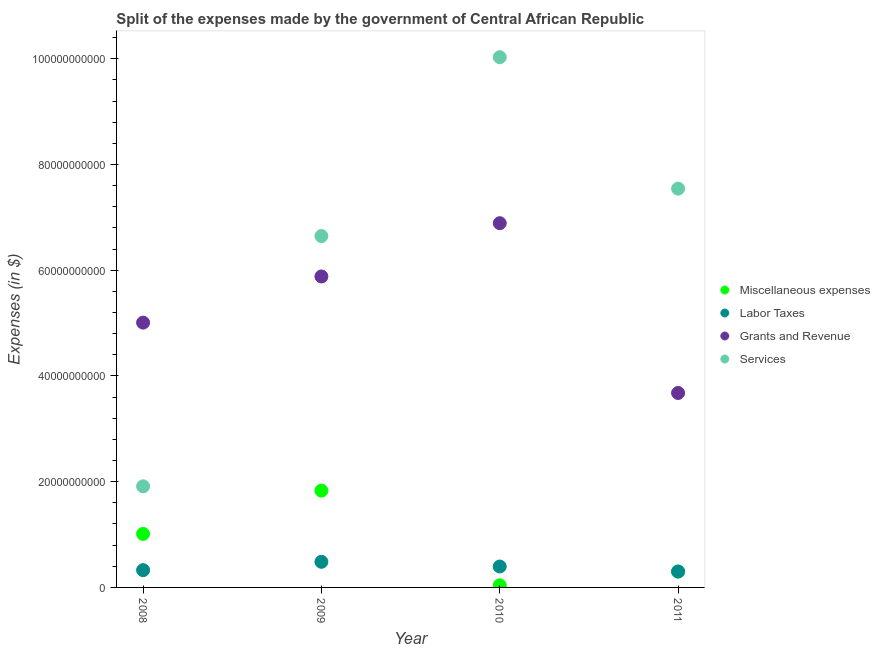How many different coloured dotlines are there?
Provide a short and direct response. 4. What is the amount spent on labor taxes in 2011?
Provide a succinct answer. 3.01e+09. Across all years, what is the maximum amount spent on labor taxes?
Offer a terse response. 4.84e+09. Across all years, what is the minimum amount spent on labor taxes?
Ensure brevity in your answer.  3.01e+09. What is the total amount spent on services in the graph?
Ensure brevity in your answer.  2.61e+11. What is the difference between the amount spent on services in 2009 and that in 2010?
Your answer should be very brief. -3.38e+1. What is the difference between the amount spent on services in 2011 and the amount spent on grants and revenue in 2009?
Your response must be concise. 1.66e+1. What is the average amount spent on labor taxes per year?
Ensure brevity in your answer.  3.77e+09. In the year 2010, what is the difference between the amount spent on grants and revenue and amount spent on services?
Offer a very short reply. -3.14e+1. What is the ratio of the amount spent on grants and revenue in 2009 to that in 2011?
Your answer should be very brief. 1.6. What is the difference between the highest and the second highest amount spent on labor taxes?
Provide a succinct answer. 8.89e+08. What is the difference between the highest and the lowest amount spent on labor taxes?
Your answer should be very brief. 1.84e+09. In how many years, is the amount spent on labor taxes greater than the average amount spent on labor taxes taken over all years?
Provide a succinct answer. 2. Is it the case that in every year, the sum of the amount spent on labor taxes and amount spent on miscellaneous expenses is greater than the sum of amount spent on services and amount spent on grants and revenue?
Your answer should be compact. No. Is it the case that in every year, the sum of the amount spent on miscellaneous expenses and amount spent on labor taxes is greater than the amount spent on grants and revenue?
Offer a terse response. No. Does the amount spent on services monotonically increase over the years?
Give a very brief answer. No. Is the amount spent on grants and revenue strictly greater than the amount spent on labor taxes over the years?
Ensure brevity in your answer.  Yes. Is the amount spent on miscellaneous expenses strictly less than the amount spent on grants and revenue over the years?
Offer a very short reply. Yes. How many years are there in the graph?
Offer a very short reply. 4. Are the values on the major ticks of Y-axis written in scientific E-notation?
Your answer should be compact. No. Does the graph contain any zero values?
Your answer should be compact. No. Does the graph contain grids?
Your response must be concise. No. Where does the legend appear in the graph?
Make the answer very short. Center right. What is the title of the graph?
Your answer should be very brief. Split of the expenses made by the government of Central African Republic. Does "Environmental sustainability" appear as one of the legend labels in the graph?
Offer a very short reply. No. What is the label or title of the Y-axis?
Ensure brevity in your answer.  Expenses (in $). What is the Expenses (in $) of Miscellaneous expenses in 2008?
Make the answer very short. 1.01e+1. What is the Expenses (in $) in Labor Taxes in 2008?
Offer a terse response. 3.27e+09. What is the Expenses (in $) in Grants and Revenue in 2008?
Give a very brief answer. 5.01e+1. What is the Expenses (in $) of Services in 2008?
Provide a succinct answer. 1.91e+1. What is the Expenses (in $) in Miscellaneous expenses in 2009?
Offer a terse response. 1.83e+1. What is the Expenses (in $) in Labor Taxes in 2009?
Make the answer very short. 4.84e+09. What is the Expenses (in $) in Grants and Revenue in 2009?
Your answer should be very brief. 5.88e+1. What is the Expenses (in $) in Services in 2009?
Your response must be concise. 6.65e+1. What is the Expenses (in $) of Miscellaneous expenses in 2010?
Provide a succinct answer. 4.00e+08. What is the Expenses (in $) of Labor Taxes in 2010?
Provide a succinct answer. 3.96e+09. What is the Expenses (in $) in Grants and Revenue in 2010?
Offer a terse response. 6.89e+1. What is the Expenses (in $) in Services in 2010?
Your answer should be compact. 1.00e+11. What is the Expenses (in $) in Miscellaneous expenses in 2011?
Provide a short and direct response. 3.00e+09. What is the Expenses (in $) of Labor Taxes in 2011?
Provide a short and direct response. 3.01e+09. What is the Expenses (in $) in Grants and Revenue in 2011?
Make the answer very short. 3.68e+1. What is the Expenses (in $) of Services in 2011?
Provide a succinct answer. 7.54e+1. Across all years, what is the maximum Expenses (in $) in Miscellaneous expenses?
Give a very brief answer. 1.83e+1. Across all years, what is the maximum Expenses (in $) of Labor Taxes?
Provide a short and direct response. 4.84e+09. Across all years, what is the maximum Expenses (in $) of Grants and Revenue?
Your answer should be compact. 6.89e+1. Across all years, what is the maximum Expenses (in $) in Services?
Make the answer very short. 1.00e+11. Across all years, what is the minimum Expenses (in $) in Miscellaneous expenses?
Your response must be concise. 4.00e+08. Across all years, what is the minimum Expenses (in $) in Labor Taxes?
Give a very brief answer. 3.01e+09. Across all years, what is the minimum Expenses (in $) in Grants and Revenue?
Offer a terse response. 3.68e+1. Across all years, what is the minimum Expenses (in $) in Services?
Ensure brevity in your answer.  1.91e+1. What is the total Expenses (in $) in Miscellaneous expenses in the graph?
Give a very brief answer. 3.18e+1. What is the total Expenses (in $) of Labor Taxes in the graph?
Provide a succinct answer. 1.51e+1. What is the total Expenses (in $) of Grants and Revenue in the graph?
Make the answer very short. 2.15e+11. What is the total Expenses (in $) of Services in the graph?
Provide a short and direct response. 2.61e+11. What is the difference between the Expenses (in $) in Miscellaneous expenses in 2008 and that in 2009?
Keep it short and to the point. -8.19e+09. What is the difference between the Expenses (in $) in Labor Taxes in 2008 and that in 2009?
Offer a very short reply. -1.58e+09. What is the difference between the Expenses (in $) of Grants and Revenue in 2008 and that in 2009?
Offer a very short reply. -8.74e+09. What is the difference between the Expenses (in $) of Services in 2008 and that in 2009?
Provide a succinct answer. -4.73e+1. What is the difference between the Expenses (in $) in Miscellaneous expenses in 2008 and that in 2010?
Ensure brevity in your answer.  9.72e+09. What is the difference between the Expenses (in $) in Labor Taxes in 2008 and that in 2010?
Provide a succinct answer. -6.89e+08. What is the difference between the Expenses (in $) of Grants and Revenue in 2008 and that in 2010?
Your answer should be compact. -1.88e+1. What is the difference between the Expenses (in $) in Services in 2008 and that in 2010?
Offer a very short reply. -8.12e+1. What is the difference between the Expenses (in $) of Miscellaneous expenses in 2008 and that in 2011?
Make the answer very short. 7.12e+09. What is the difference between the Expenses (in $) in Labor Taxes in 2008 and that in 2011?
Your answer should be very brief. 2.58e+08. What is the difference between the Expenses (in $) in Grants and Revenue in 2008 and that in 2011?
Your answer should be very brief. 1.33e+1. What is the difference between the Expenses (in $) of Services in 2008 and that in 2011?
Give a very brief answer. -5.63e+1. What is the difference between the Expenses (in $) of Miscellaneous expenses in 2009 and that in 2010?
Your response must be concise. 1.79e+1. What is the difference between the Expenses (in $) in Labor Taxes in 2009 and that in 2010?
Provide a short and direct response. 8.89e+08. What is the difference between the Expenses (in $) in Grants and Revenue in 2009 and that in 2010?
Offer a terse response. -1.01e+1. What is the difference between the Expenses (in $) in Services in 2009 and that in 2010?
Provide a short and direct response. -3.38e+1. What is the difference between the Expenses (in $) of Miscellaneous expenses in 2009 and that in 2011?
Your answer should be very brief. 1.53e+1. What is the difference between the Expenses (in $) of Labor Taxes in 2009 and that in 2011?
Give a very brief answer. 1.84e+09. What is the difference between the Expenses (in $) in Grants and Revenue in 2009 and that in 2011?
Your response must be concise. 2.20e+1. What is the difference between the Expenses (in $) of Services in 2009 and that in 2011?
Offer a very short reply. -8.97e+09. What is the difference between the Expenses (in $) in Miscellaneous expenses in 2010 and that in 2011?
Provide a succinct answer. -2.60e+09. What is the difference between the Expenses (in $) of Labor Taxes in 2010 and that in 2011?
Provide a short and direct response. 9.47e+08. What is the difference between the Expenses (in $) in Grants and Revenue in 2010 and that in 2011?
Give a very brief answer. 3.21e+1. What is the difference between the Expenses (in $) in Services in 2010 and that in 2011?
Your answer should be very brief. 2.49e+1. What is the difference between the Expenses (in $) of Miscellaneous expenses in 2008 and the Expenses (in $) of Labor Taxes in 2009?
Keep it short and to the point. 5.28e+09. What is the difference between the Expenses (in $) of Miscellaneous expenses in 2008 and the Expenses (in $) of Grants and Revenue in 2009?
Ensure brevity in your answer.  -4.87e+1. What is the difference between the Expenses (in $) of Miscellaneous expenses in 2008 and the Expenses (in $) of Services in 2009?
Your answer should be compact. -5.63e+1. What is the difference between the Expenses (in $) of Labor Taxes in 2008 and the Expenses (in $) of Grants and Revenue in 2009?
Your answer should be compact. -5.56e+1. What is the difference between the Expenses (in $) in Labor Taxes in 2008 and the Expenses (in $) in Services in 2009?
Give a very brief answer. -6.32e+1. What is the difference between the Expenses (in $) of Grants and Revenue in 2008 and the Expenses (in $) of Services in 2009?
Provide a short and direct response. -1.64e+1. What is the difference between the Expenses (in $) in Miscellaneous expenses in 2008 and the Expenses (in $) in Labor Taxes in 2010?
Give a very brief answer. 6.17e+09. What is the difference between the Expenses (in $) in Miscellaneous expenses in 2008 and the Expenses (in $) in Grants and Revenue in 2010?
Your answer should be compact. -5.88e+1. What is the difference between the Expenses (in $) in Miscellaneous expenses in 2008 and the Expenses (in $) in Services in 2010?
Provide a succinct answer. -9.02e+1. What is the difference between the Expenses (in $) of Labor Taxes in 2008 and the Expenses (in $) of Grants and Revenue in 2010?
Provide a succinct answer. -6.56e+1. What is the difference between the Expenses (in $) of Labor Taxes in 2008 and the Expenses (in $) of Services in 2010?
Make the answer very short. -9.70e+1. What is the difference between the Expenses (in $) of Grants and Revenue in 2008 and the Expenses (in $) of Services in 2010?
Your response must be concise. -5.02e+1. What is the difference between the Expenses (in $) of Miscellaneous expenses in 2008 and the Expenses (in $) of Labor Taxes in 2011?
Offer a very short reply. 7.11e+09. What is the difference between the Expenses (in $) in Miscellaneous expenses in 2008 and the Expenses (in $) in Grants and Revenue in 2011?
Your response must be concise. -2.67e+1. What is the difference between the Expenses (in $) in Miscellaneous expenses in 2008 and the Expenses (in $) in Services in 2011?
Your answer should be very brief. -6.53e+1. What is the difference between the Expenses (in $) in Labor Taxes in 2008 and the Expenses (in $) in Grants and Revenue in 2011?
Ensure brevity in your answer.  -3.35e+1. What is the difference between the Expenses (in $) in Labor Taxes in 2008 and the Expenses (in $) in Services in 2011?
Your answer should be very brief. -7.22e+1. What is the difference between the Expenses (in $) in Grants and Revenue in 2008 and the Expenses (in $) in Services in 2011?
Offer a terse response. -2.53e+1. What is the difference between the Expenses (in $) of Miscellaneous expenses in 2009 and the Expenses (in $) of Labor Taxes in 2010?
Keep it short and to the point. 1.44e+1. What is the difference between the Expenses (in $) in Miscellaneous expenses in 2009 and the Expenses (in $) in Grants and Revenue in 2010?
Ensure brevity in your answer.  -5.06e+1. What is the difference between the Expenses (in $) in Miscellaneous expenses in 2009 and the Expenses (in $) in Services in 2010?
Provide a short and direct response. -8.20e+1. What is the difference between the Expenses (in $) in Labor Taxes in 2009 and the Expenses (in $) in Grants and Revenue in 2010?
Offer a very short reply. -6.41e+1. What is the difference between the Expenses (in $) in Labor Taxes in 2009 and the Expenses (in $) in Services in 2010?
Your answer should be compact. -9.54e+1. What is the difference between the Expenses (in $) in Grants and Revenue in 2009 and the Expenses (in $) in Services in 2010?
Keep it short and to the point. -4.15e+1. What is the difference between the Expenses (in $) in Miscellaneous expenses in 2009 and the Expenses (in $) in Labor Taxes in 2011?
Ensure brevity in your answer.  1.53e+1. What is the difference between the Expenses (in $) in Miscellaneous expenses in 2009 and the Expenses (in $) in Grants and Revenue in 2011?
Give a very brief answer. -1.85e+1. What is the difference between the Expenses (in $) of Miscellaneous expenses in 2009 and the Expenses (in $) of Services in 2011?
Your answer should be very brief. -5.71e+1. What is the difference between the Expenses (in $) in Labor Taxes in 2009 and the Expenses (in $) in Grants and Revenue in 2011?
Make the answer very short. -3.19e+1. What is the difference between the Expenses (in $) of Labor Taxes in 2009 and the Expenses (in $) of Services in 2011?
Ensure brevity in your answer.  -7.06e+1. What is the difference between the Expenses (in $) of Grants and Revenue in 2009 and the Expenses (in $) of Services in 2011?
Provide a succinct answer. -1.66e+1. What is the difference between the Expenses (in $) in Miscellaneous expenses in 2010 and the Expenses (in $) in Labor Taxes in 2011?
Keep it short and to the point. -2.61e+09. What is the difference between the Expenses (in $) in Miscellaneous expenses in 2010 and the Expenses (in $) in Grants and Revenue in 2011?
Ensure brevity in your answer.  -3.64e+1. What is the difference between the Expenses (in $) in Miscellaneous expenses in 2010 and the Expenses (in $) in Services in 2011?
Your answer should be compact. -7.50e+1. What is the difference between the Expenses (in $) in Labor Taxes in 2010 and the Expenses (in $) in Grants and Revenue in 2011?
Ensure brevity in your answer.  -3.28e+1. What is the difference between the Expenses (in $) of Labor Taxes in 2010 and the Expenses (in $) of Services in 2011?
Ensure brevity in your answer.  -7.15e+1. What is the difference between the Expenses (in $) of Grants and Revenue in 2010 and the Expenses (in $) of Services in 2011?
Keep it short and to the point. -6.54e+09. What is the average Expenses (in $) of Miscellaneous expenses per year?
Your answer should be very brief. 7.96e+09. What is the average Expenses (in $) in Labor Taxes per year?
Make the answer very short. 3.77e+09. What is the average Expenses (in $) of Grants and Revenue per year?
Offer a terse response. 5.36e+1. What is the average Expenses (in $) of Services per year?
Ensure brevity in your answer.  6.53e+1. In the year 2008, what is the difference between the Expenses (in $) of Miscellaneous expenses and Expenses (in $) of Labor Taxes?
Your response must be concise. 6.85e+09. In the year 2008, what is the difference between the Expenses (in $) of Miscellaneous expenses and Expenses (in $) of Grants and Revenue?
Provide a succinct answer. -4.00e+1. In the year 2008, what is the difference between the Expenses (in $) in Miscellaneous expenses and Expenses (in $) in Services?
Offer a terse response. -9.00e+09. In the year 2008, what is the difference between the Expenses (in $) in Labor Taxes and Expenses (in $) in Grants and Revenue?
Offer a terse response. -4.68e+1. In the year 2008, what is the difference between the Expenses (in $) of Labor Taxes and Expenses (in $) of Services?
Your answer should be very brief. -1.59e+1. In the year 2008, what is the difference between the Expenses (in $) of Grants and Revenue and Expenses (in $) of Services?
Offer a very short reply. 3.10e+1. In the year 2009, what is the difference between the Expenses (in $) of Miscellaneous expenses and Expenses (in $) of Labor Taxes?
Your answer should be very brief. 1.35e+1. In the year 2009, what is the difference between the Expenses (in $) in Miscellaneous expenses and Expenses (in $) in Grants and Revenue?
Your response must be concise. -4.05e+1. In the year 2009, what is the difference between the Expenses (in $) in Miscellaneous expenses and Expenses (in $) in Services?
Offer a terse response. -4.82e+1. In the year 2009, what is the difference between the Expenses (in $) of Labor Taxes and Expenses (in $) of Grants and Revenue?
Offer a very short reply. -5.40e+1. In the year 2009, what is the difference between the Expenses (in $) of Labor Taxes and Expenses (in $) of Services?
Your response must be concise. -6.16e+1. In the year 2009, what is the difference between the Expenses (in $) in Grants and Revenue and Expenses (in $) in Services?
Your answer should be very brief. -7.64e+09. In the year 2010, what is the difference between the Expenses (in $) of Miscellaneous expenses and Expenses (in $) of Labor Taxes?
Offer a very short reply. -3.56e+09. In the year 2010, what is the difference between the Expenses (in $) in Miscellaneous expenses and Expenses (in $) in Grants and Revenue?
Provide a succinct answer. -6.85e+1. In the year 2010, what is the difference between the Expenses (in $) of Miscellaneous expenses and Expenses (in $) of Services?
Your answer should be compact. -9.99e+1. In the year 2010, what is the difference between the Expenses (in $) of Labor Taxes and Expenses (in $) of Grants and Revenue?
Your answer should be compact. -6.49e+1. In the year 2010, what is the difference between the Expenses (in $) in Labor Taxes and Expenses (in $) in Services?
Your response must be concise. -9.63e+1. In the year 2010, what is the difference between the Expenses (in $) in Grants and Revenue and Expenses (in $) in Services?
Ensure brevity in your answer.  -3.14e+1. In the year 2011, what is the difference between the Expenses (in $) of Miscellaneous expenses and Expenses (in $) of Labor Taxes?
Offer a very short reply. -9.54e+06. In the year 2011, what is the difference between the Expenses (in $) of Miscellaneous expenses and Expenses (in $) of Grants and Revenue?
Your answer should be compact. -3.38e+1. In the year 2011, what is the difference between the Expenses (in $) in Miscellaneous expenses and Expenses (in $) in Services?
Offer a very short reply. -7.24e+1. In the year 2011, what is the difference between the Expenses (in $) of Labor Taxes and Expenses (in $) of Grants and Revenue?
Offer a very short reply. -3.38e+1. In the year 2011, what is the difference between the Expenses (in $) of Labor Taxes and Expenses (in $) of Services?
Provide a short and direct response. -7.24e+1. In the year 2011, what is the difference between the Expenses (in $) of Grants and Revenue and Expenses (in $) of Services?
Offer a very short reply. -3.87e+1. What is the ratio of the Expenses (in $) in Miscellaneous expenses in 2008 to that in 2009?
Offer a very short reply. 0.55. What is the ratio of the Expenses (in $) in Labor Taxes in 2008 to that in 2009?
Provide a succinct answer. 0.67. What is the ratio of the Expenses (in $) of Grants and Revenue in 2008 to that in 2009?
Ensure brevity in your answer.  0.85. What is the ratio of the Expenses (in $) in Services in 2008 to that in 2009?
Your response must be concise. 0.29. What is the ratio of the Expenses (in $) of Miscellaneous expenses in 2008 to that in 2010?
Give a very brief answer. 25.3. What is the ratio of the Expenses (in $) in Labor Taxes in 2008 to that in 2010?
Provide a short and direct response. 0.83. What is the ratio of the Expenses (in $) of Grants and Revenue in 2008 to that in 2010?
Ensure brevity in your answer.  0.73. What is the ratio of the Expenses (in $) of Services in 2008 to that in 2010?
Keep it short and to the point. 0.19. What is the ratio of the Expenses (in $) in Miscellaneous expenses in 2008 to that in 2011?
Make the answer very short. 3.37. What is the ratio of the Expenses (in $) in Labor Taxes in 2008 to that in 2011?
Your answer should be very brief. 1.09. What is the ratio of the Expenses (in $) of Grants and Revenue in 2008 to that in 2011?
Make the answer very short. 1.36. What is the ratio of the Expenses (in $) of Services in 2008 to that in 2011?
Keep it short and to the point. 0.25. What is the ratio of the Expenses (in $) in Miscellaneous expenses in 2009 to that in 2010?
Your answer should be compact. 45.77. What is the ratio of the Expenses (in $) of Labor Taxes in 2009 to that in 2010?
Provide a succinct answer. 1.22. What is the ratio of the Expenses (in $) in Grants and Revenue in 2009 to that in 2010?
Ensure brevity in your answer.  0.85. What is the ratio of the Expenses (in $) of Services in 2009 to that in 2010?
Give a very brief answer. 0.66. What is the ratio of the Expenses (in $) of Miscellaneous expenses in 2009 to that in 2011?
Your response must be concise. 6.1. What is the ratio of the Expenses (in $) of Labor Taxes in 2009 to that in 2011?
Offer a terse response. 1.61. What is the ratio of the Expenses (in $) in Grants and Revenue in 2009 to that in 2011?
Make the answer very short. 1.6. What is the ratio of the Expenses (in $) in Services in 2009 to that in 2011?
Your answer should be very brief. 0.88. What is the ratio of the Expenses (in $) of Miscellaneous expenses in 2010 to that in 2011?
Provide a short and direct response. 0.13. What is the ratio of the Expenses (in $) in Labor Taxes in 2010 to that in 2011?
Provide a short and direct response. 1.31. What is the ratio of the Expenses (in $) in Grants and Revenue in 2010 to that in 2011?
Make the answer very short. 1.87. What is the ratio of the Expenses (in $) in Services in 2010 to that in 2011?
Keep it short and to the point. 1.33. What is the difference between the highest and the second highest Expenses (in $) in Miscellaneous expenses?
Provide a succinct answer. 8.19e+09. What is the difference between the highest and the second highest Expenses (in $) of Labor Taxes?
Provide a short and direct response. 8.89e+08. What is the difference between the highest and the second highest Expenses (in $) of Grants and Revenue?
Offer a terse response. 1.01e+1. What is the difference between the highest and the second highest Expenses (in $) of Services?
Ensure brevity in your answer.  2.49e+1. What is the difference between the highest and the lowest Expenses (in $) of Miscellaneous expenses?
Give a very brief answer. 1.79e+1. What is the difference between the highest and the lowest Expenses (in $) in Labor Taxes?
Provide a succinct answer. 1.84e+09. What is the difference between the highest and the lowest Expenses (in $) in Grants and Revenue?
Give a very brief answer. 3.21e+1. What is the difference between the highest and the lowest Expenses (in $) in Services?
Your answer should be compact. 8.12e+1. 